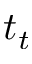<formula> <loc_0><loc_0><loc_500><loc_500>t _ { t }</formula> 